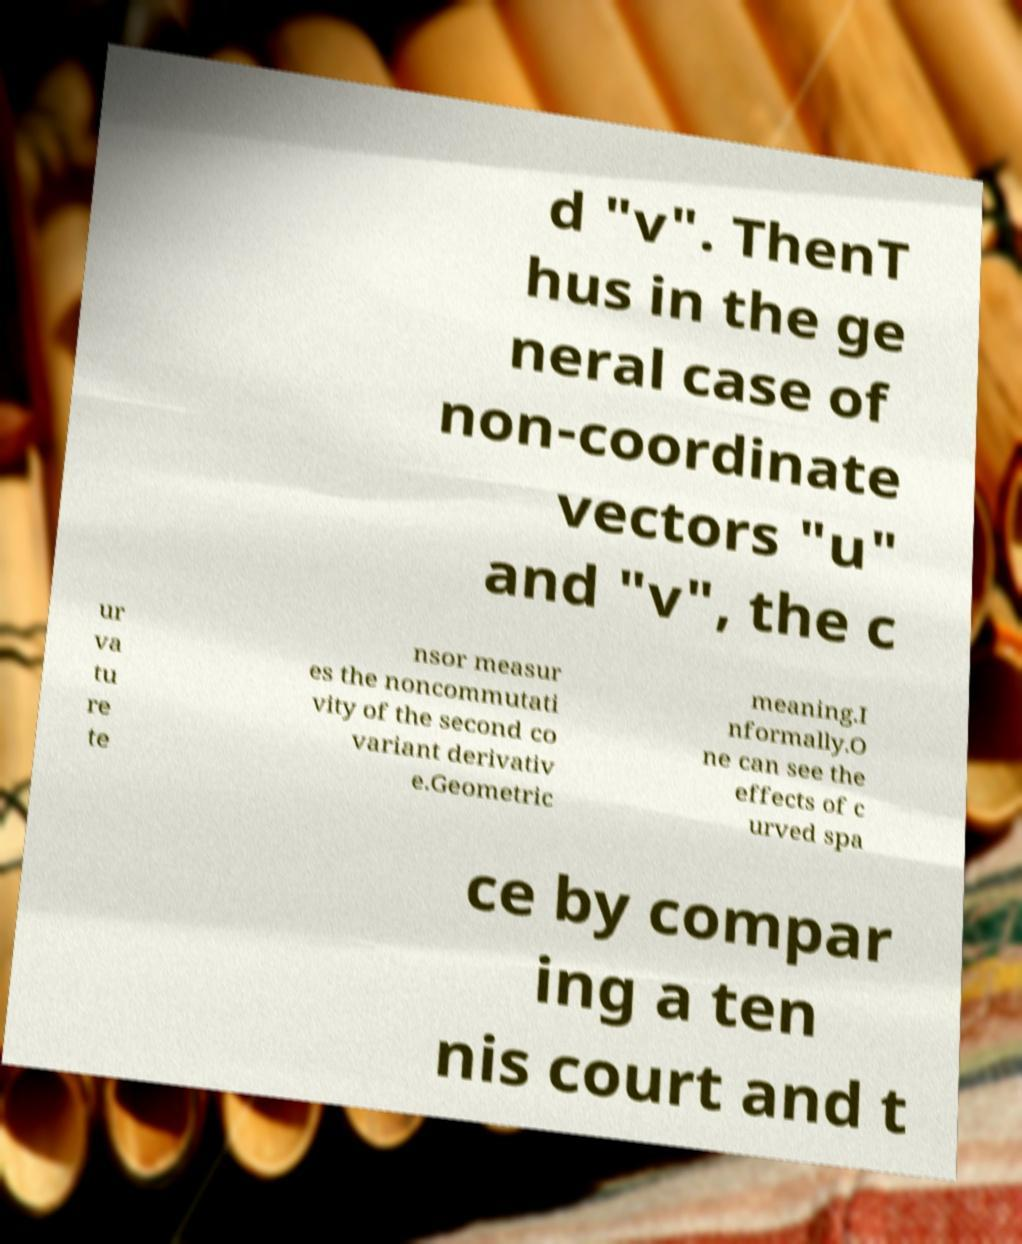Could you assist in decoding the text presented in this image and type it out clearly? d "v". ThenT hus in the ge neral case of non-coordinate vectors "u" and "v", the c ur va tu re te nsor measur es the noncommutati vity of the second co variant derivativ e.Geometric meaning.I nformally.O ne can see the effects of c urved spa ce by compar ing a ten nis court and t 